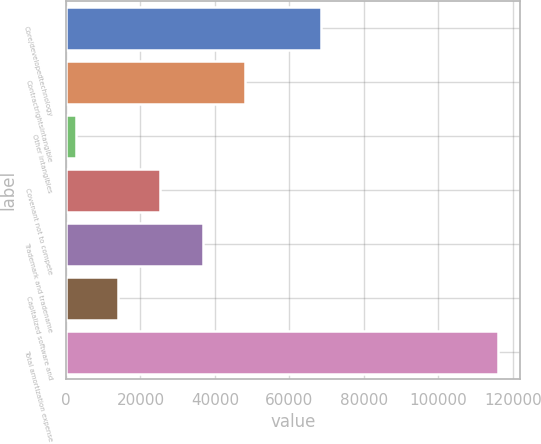Convert chart to OTSL. <chart><loc_0><loc_0><loc_500><loc_500><bar_chart><fcel>Core/developedtechnology<fcel>Contractrightsintangible<fcel>Other intangibles<fcel>Covenant not to compete<fcel>Trademark and tradename<fcel>Capitalized software and<fcel>Total amortization expense<nl><fcel>68390<fcel>48050<fcel>2654<fcel>25352<fcel>36701<fcel>14003<fcel>116144<nl></chart> 